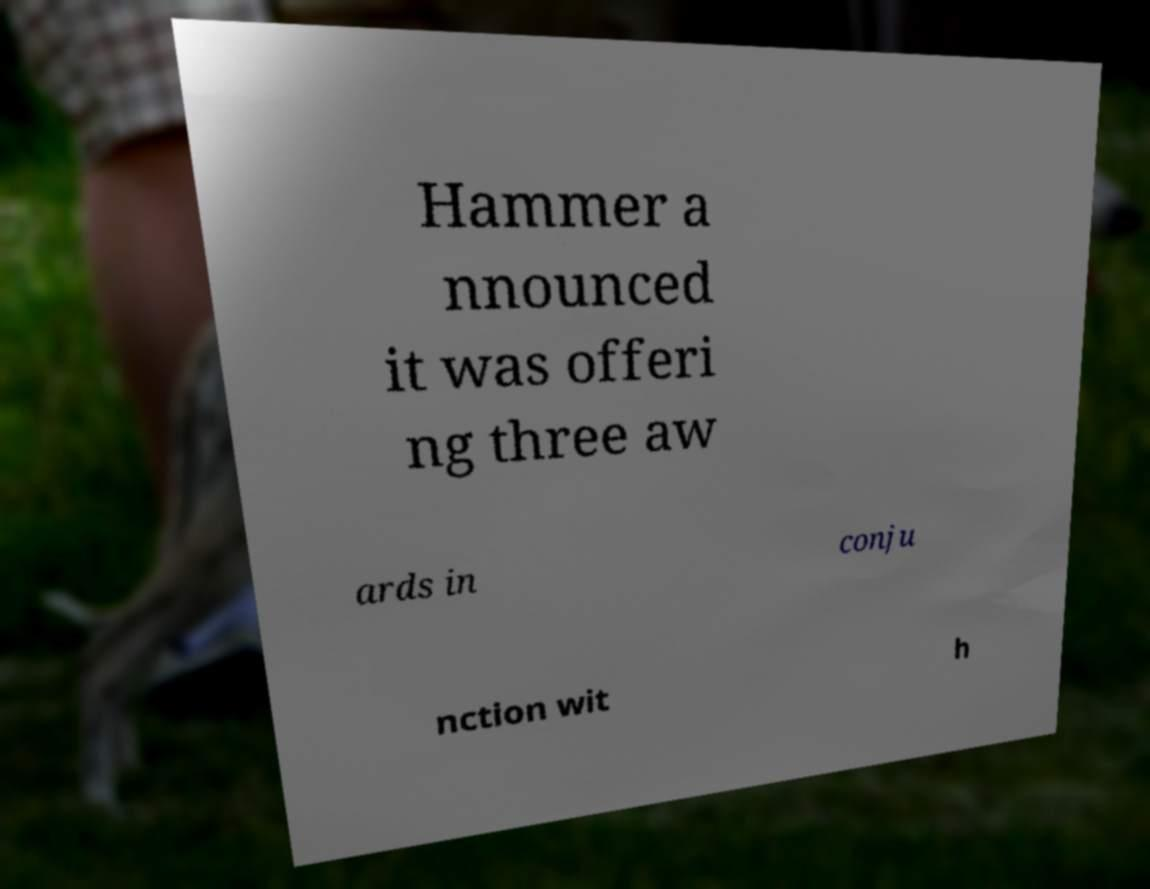Please read and relay the text visible in this image. What does it say? Hammer a nnounced it was offeri ng three aw ards in conju nction wit h 